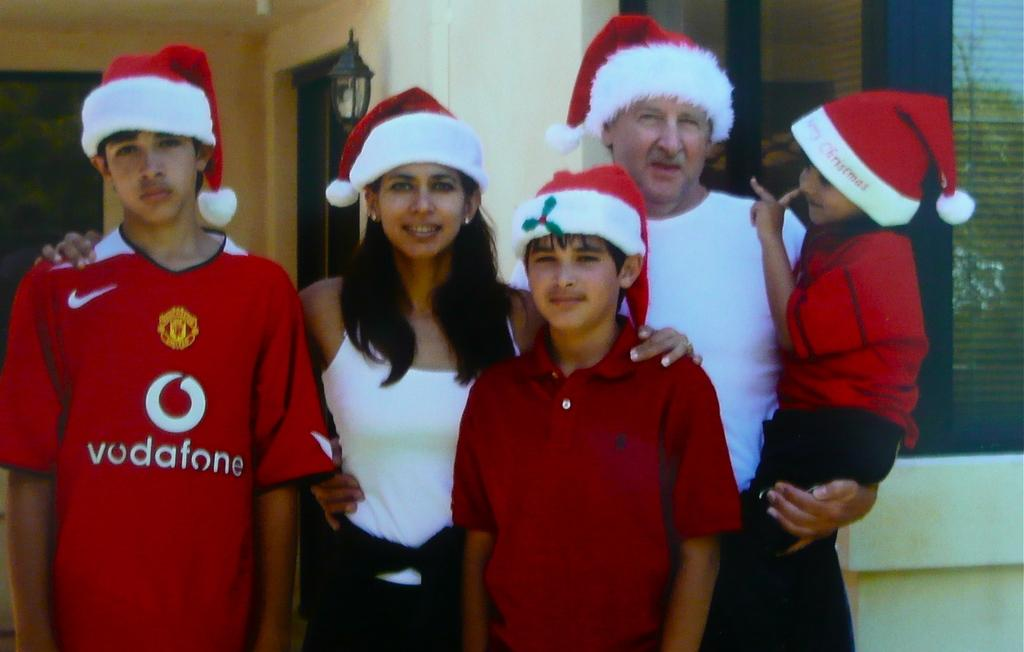What can be seen in the image? There are people standing in the image. What is visible in the background of the image? There is a house in the background of the image. How many beggars are present in the image? There is no mention of beggars in the image, so it cannot be determined how many are present. 